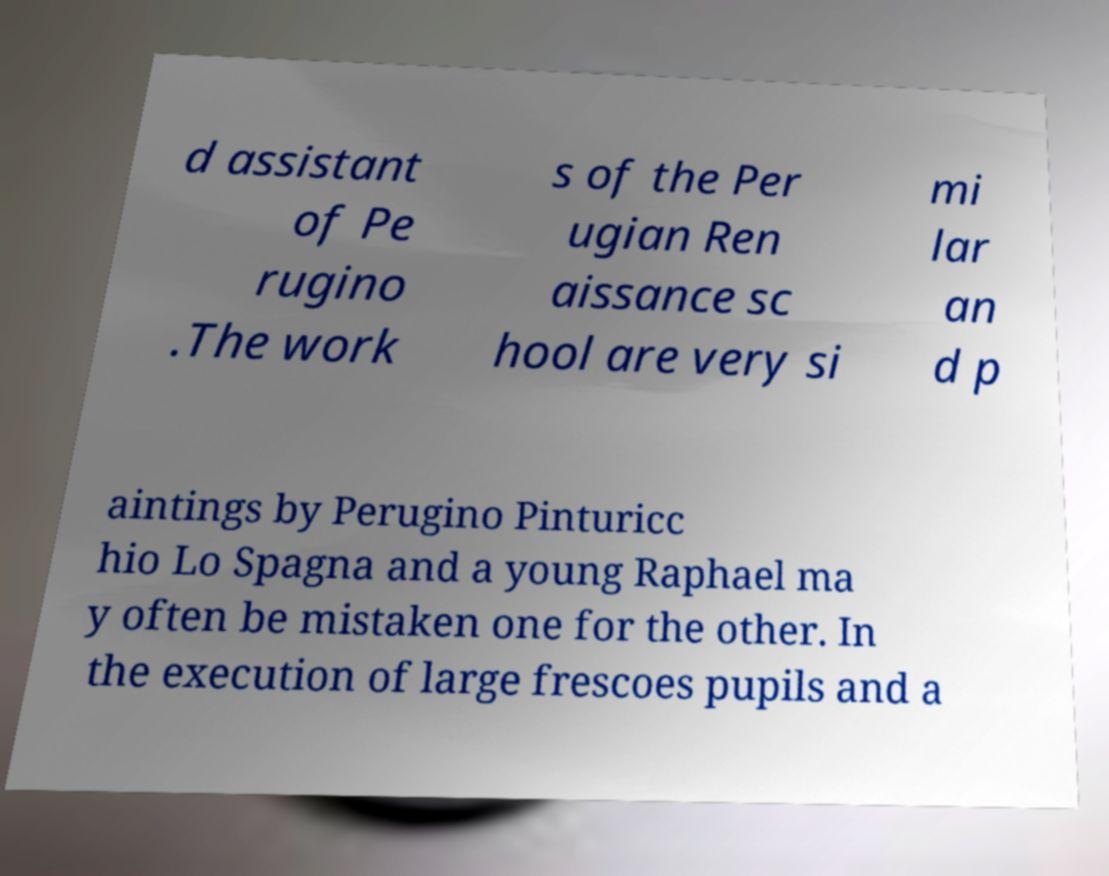Can you read and provide the text displayed in the image?This photo seems to have some interesting text. Can you extract and type it out for me? d assistant of Pe rugino .The work s of the Per ugian Ren aissance sc hool are very si mi lar an d p aintings by Perugino Pinturicc hio Lo Spagna and a young Raphael ma y often be mistaken one for the other. In the execution of large frescoes pupils and a 